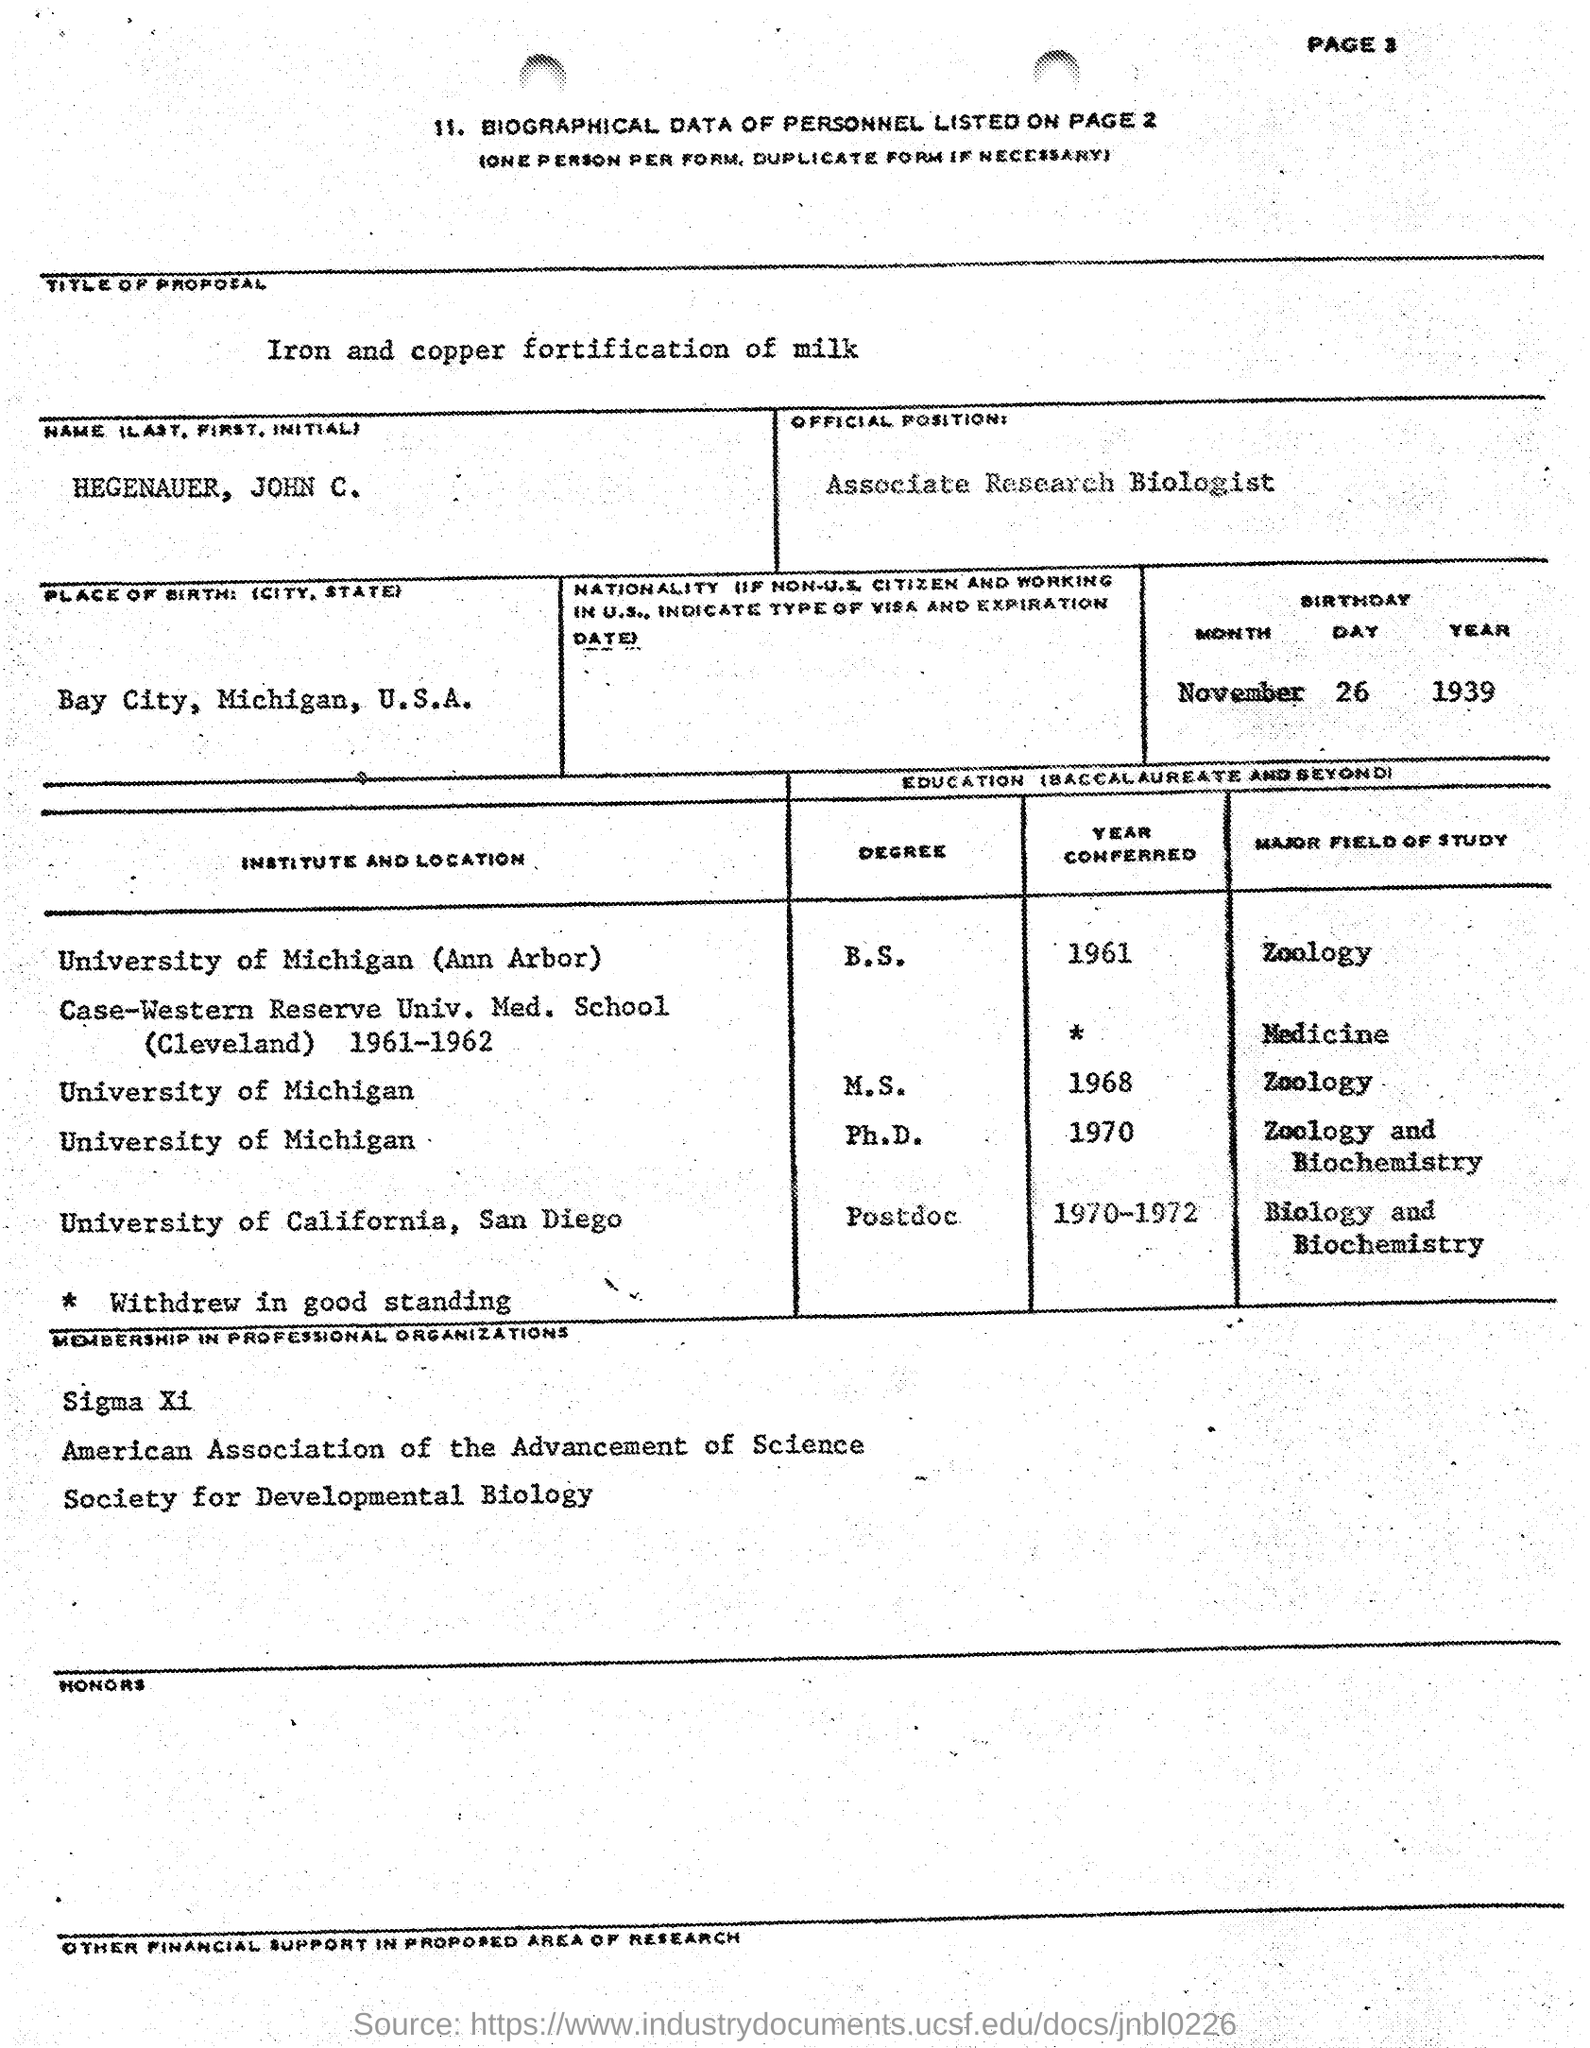Draw attention to some important aspects in this diagram. The date of birth of the individual is November 26, 1939. The biographical data of personnel is located on page 2. The official position is that of an Associate Research Biologist. The place of birth is Bay City, Michigan, in the United States of America. The proposal is titled "Iron and Copper Fortification of Milk. 